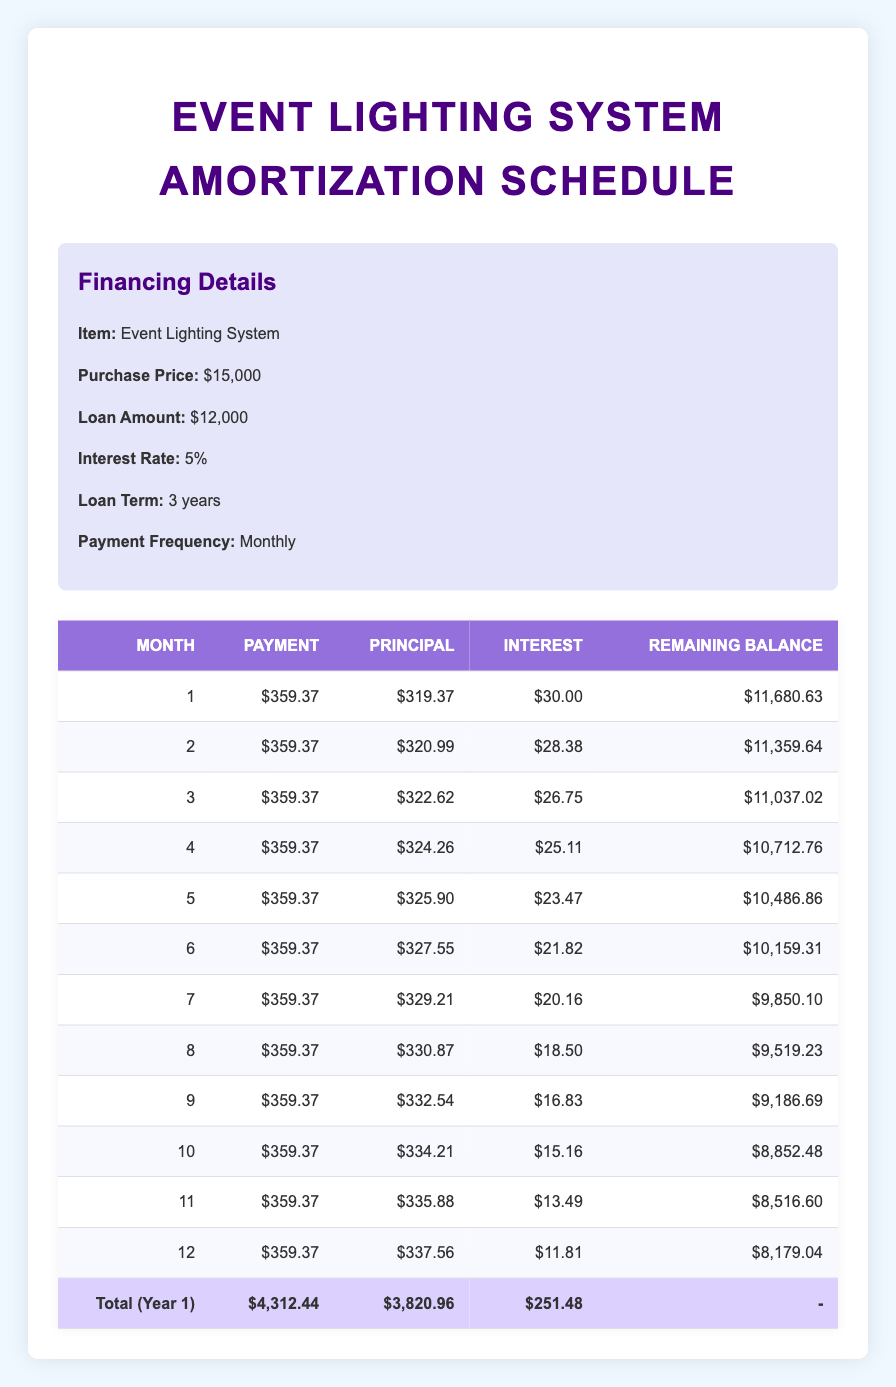What is the total payment made in the first year? By summing the monthly payments for the first year, which are all equal to 359.37, we calculate 359.37 * 12 = 4,312.44 for the total payment.
Answer: 4,312.44 How much principal is paid off after the first month? The principal amount for the first month is directly stated in the table as 319.37.
Answer: 319.37 What is the remaining balance after 6 months? The remaining balance after 6 months is listed in the table as 10,159.31.
Answer: 10,159.31 Is the interest payment in the 12th month higher than the interest payment in the 1st month? The interest payment in the 1st month is 30.00, while in the 12th month, it’s 11.81. Since 30.00 is greater than 11.81, the statement is false.
Answer: No What is the total amount of principal paid off after the first 6 months? Adding up the principal amounts from the first 6 months: 319.37 + 320.99 + 322.62 + 324.26 + 325.90 + 327.55 gives a total of 1,640.69.
Answer: 1,640.69 In which month is the lowest interest payment made? From the table, the interest payments decrease each month. The lowest interest payment, 11.81, occurs in the 12th month.
Answer: 12th month How much interest is paid in total during the first year? To find the total interest, we sum up the interest payments for all 12 months: (30.00 + 28.38 + 26.75 + 25.11 + 23.47 + 21.82 + 20.16 + 18.50 + 16.83 + 15.16 + 13.49 + 11.81) = 251.48.
Answer: 251.48 What is the average monthly payment made over the first year? The average monthly payment is calculated by dividing the total payment by 12: 4,312.44 / 12 = 359.37, as payments are consistent each month.
Answer: 359.37 How much did the remaining balance decrease from month 1 to month 12? The remaining balance decreases from 11,680.63 in month 1 to 8,179.04 in month 12. The difference is 11,680.63 - 8,179.04 = 3,501.59.
Answer: 3,501.59 